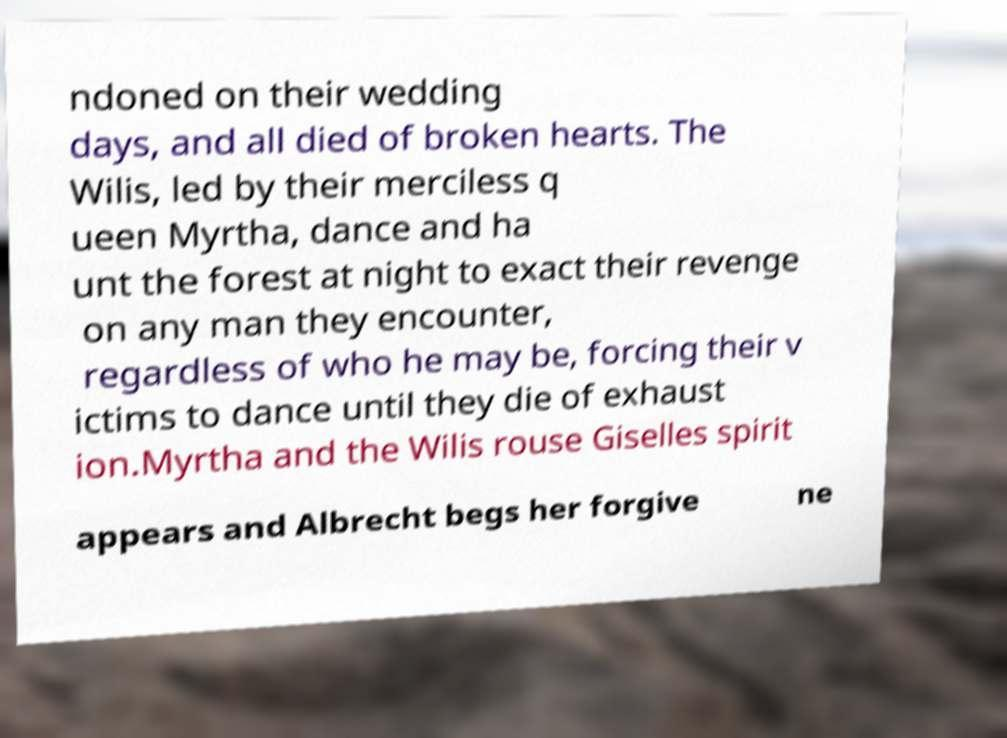Please identify and transcribe the text found in this image. ndoned on their wedding days, and all died of broken hearts. The Wilis, led by their merciless q ueen Myrtha, dance and ha unt the forest at night to exact their revenge on any man they encounter, regardless of who he may be, forcing their v ictims to dance until they die of exhaust ion.Myrtha and the Wilis rouse Giselles spirit appears and Albrecht begs her forgive ne 